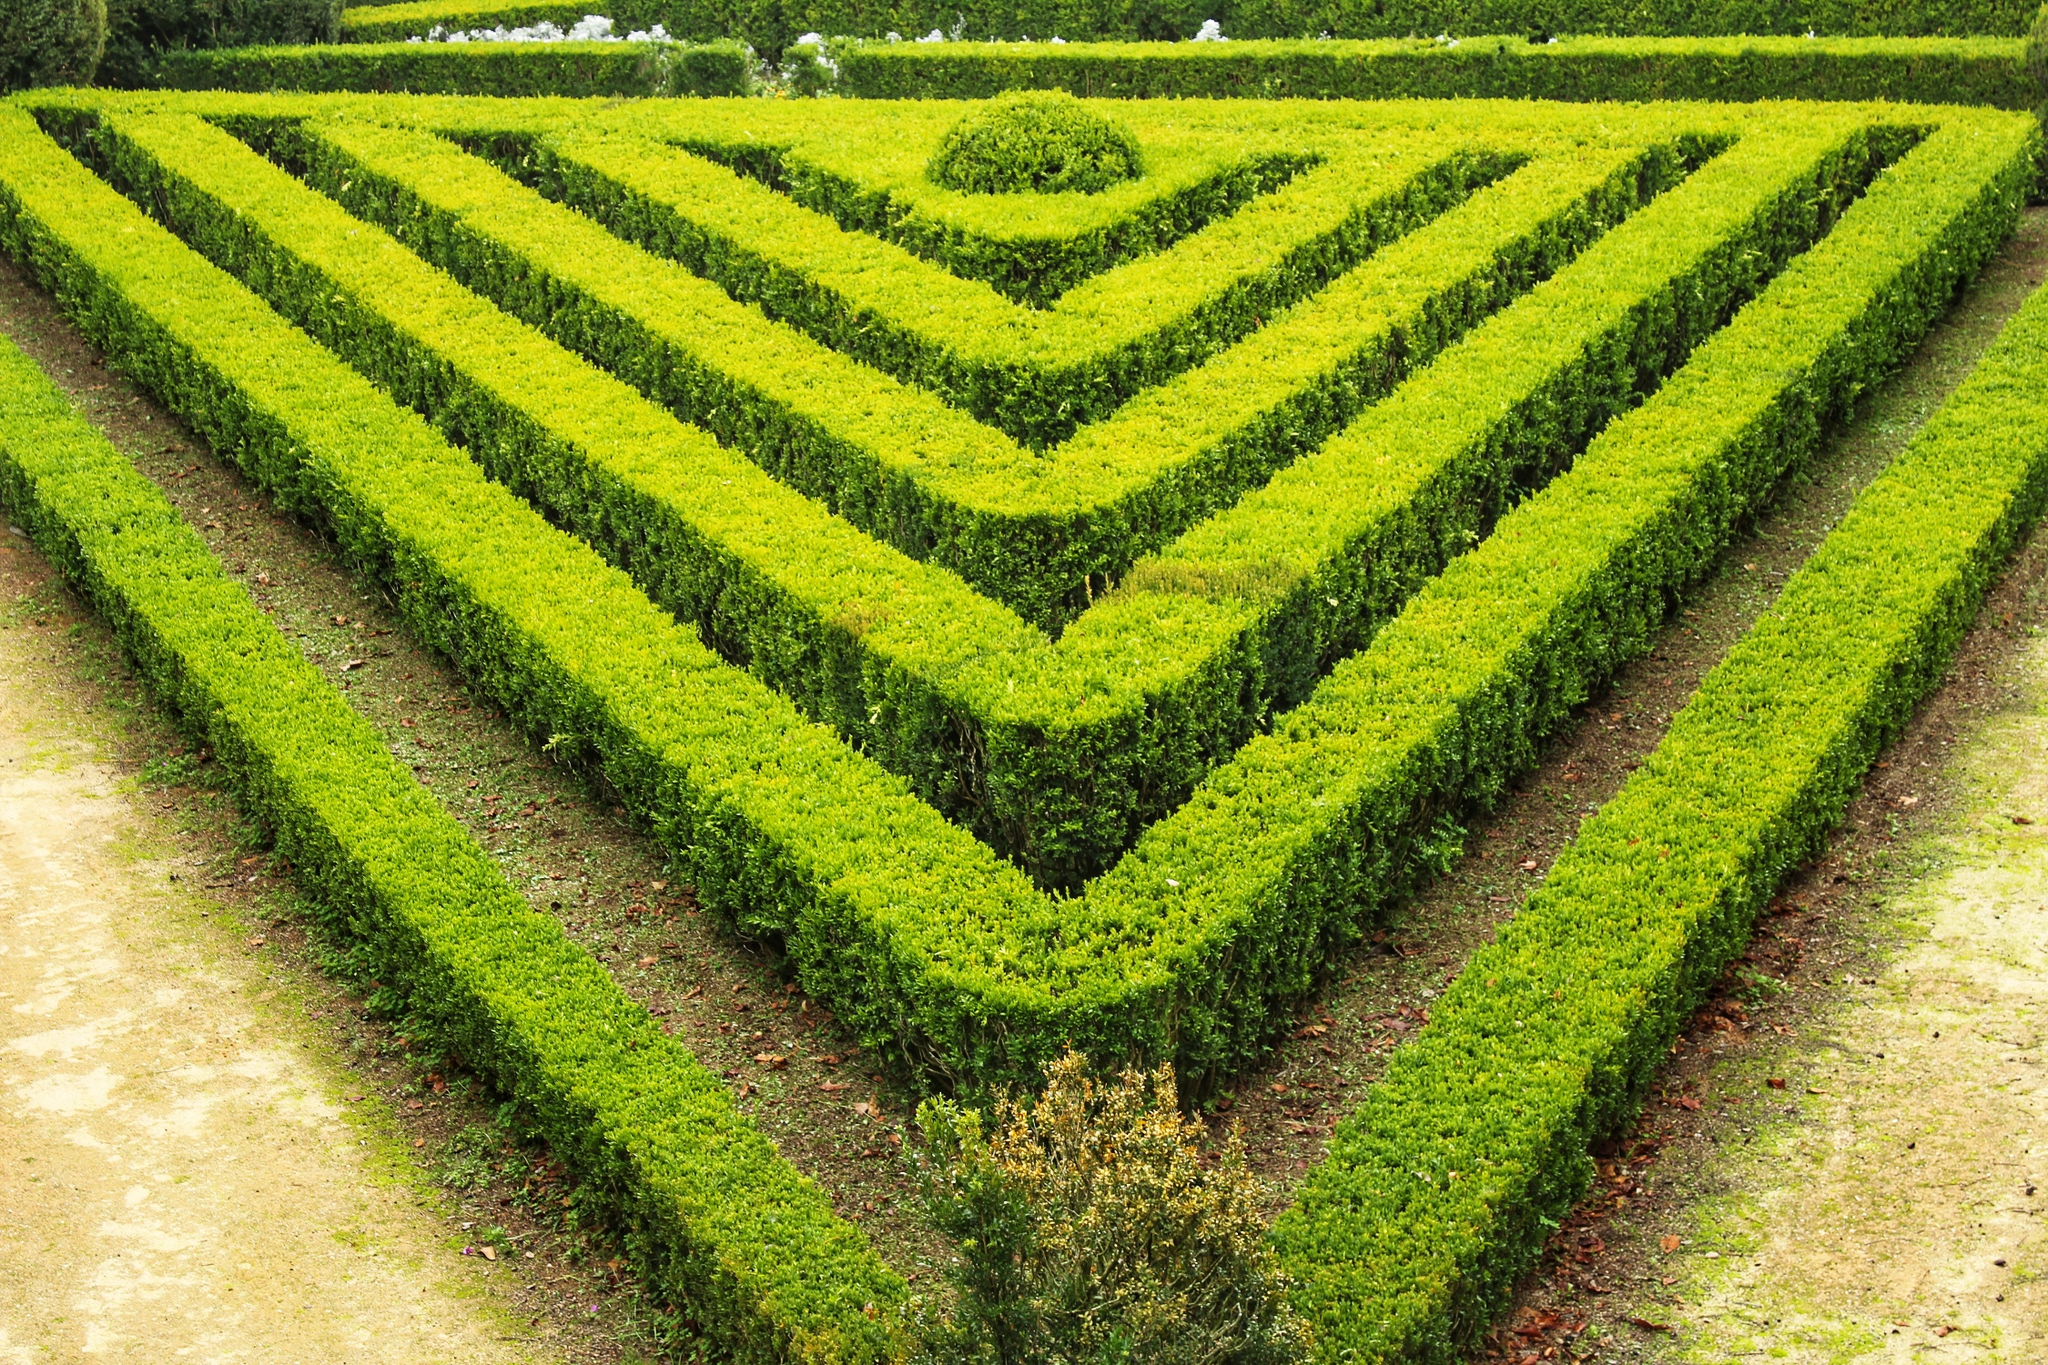What can you tell me about the artistic elements of the garden design? The garden's design is an elegant blend of art and nature, showcasing a meticulous attention to geometric structure. The rows of shrubs, arranged into nested triangles, provide a sense of order and precision akin to a carefully crafted piece of art. This arrangement not only enhances visual appeal, but it also introduces an element of depth perception, making the garden appear more expansive. The surrounding dirt path serves as a contrasting frame that hones focus on the central design. Small trees punctuate the pattern, infusing the scene with vertical accents that break up the horizontal lines of the shrubs, adding an additional layer of visual interest. Can you describe how the pathways interact with the shrubbery in more detail? Absolutely. The paths in this garden play a crucial role in defining the garden's structure. They serve as natural boundaries that elegantly contain and highlight the triangular arrangements of the shrubs. The paths, composed of a light-colored, natural dirt, create a striking contrast with the lush greenery, making the shapes of the shrubs more pronounced. These pathways also guide visitors through and around the garden, inviting exploration while maintaining the integrity of the geometric design. The interaction between the paths and the shrubbery is a harmonious balance between accessibility and aesthetics, ensuring that the garden is both pleasing to the eye and functional. Imagine this garden at sunset; how would the lighting change the perception of the garden's design? As the sun sets, the garden would transform into a mesmerizing play of light and shadow. The geometric patterns of the shrubs would cast elongated, intricate shadows across the pathways, enhancing the depth and complexity of the design. The soft, warm glow of the setting sun would highlight the vibrant greens of the shrubs, creating dynamic contrasts with the cooler tones of the shadows. This interplay of light would draw the eye along the lines and edges of the triangular patterns, emphasizing the precision of the garden's layout. The overall atmosphere would become more serene and contemplative, inviting visitors to linger and appreciate the tranquil beauty of the garden in the twilight. 